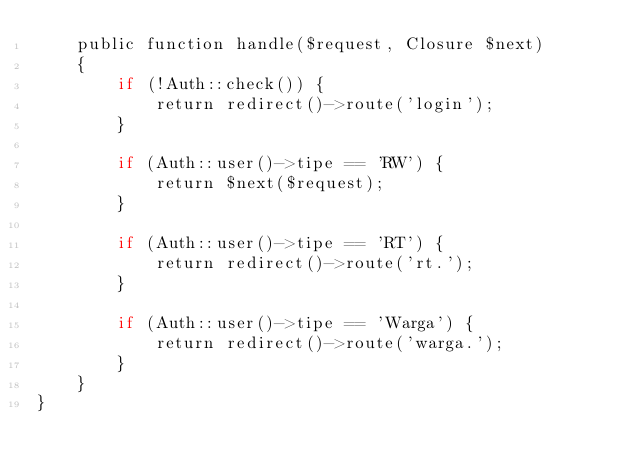Convert code to text. <code><loc_0><loc_0><loc_500><loc_500><_PHP_>    public function handle($request, Closure $next)
    {
        if (!Auth::check()) {
            return redirect()->route('login');
        }

        if (Auth::user()->tipe == 'RW') {
            return $next($request);
        }

        if (Auth::user()->tipe == 'RT') {
            return redirect()->route('rt.');
        }

        if (Auth::user()->tipe == 'Warga') {
            return redirect()->route('warga.');
        }
    }
}
</code> 